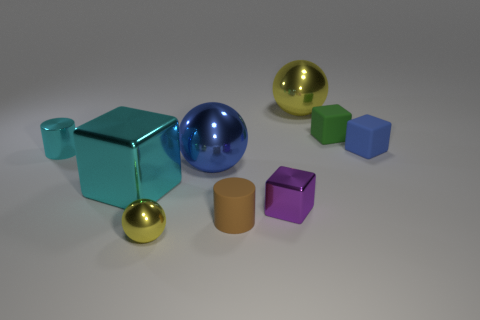What number of rubber objects are either purple blocks or large cyan cubes?
Offer a terse response. 0. Is the blue matte block the same size as the cyan metallic block?
Make the answer very short. No. Are there fewer small balls in front of the tiny brown object than small cubes that are behind the tiny cyan object?
Keep it short and to the point. Yes. How big is the blue rubber cube?
Offer a terse response. Small. What number of big objects are green matte cubes or matte things?
Your answer should be very brief. 0. Do the cyan cube and the blue thing on the left side of the purple metallic object have the same size?
Ensure brevity in your answer.  Yes. Is there any other thing that is the same shape as the large blue thing?
Your response must be concise. Yes. What number of red rubber spheres are there?
Provide a short and direct response. 0. What number of cyan things are tiny rubber cylinders or shiny cylinders?
Offer a terse response. 1. Are the object in front of the tiny brown thing and the large yellow object made of the same material?
Keep it short and to the point. Yes. 